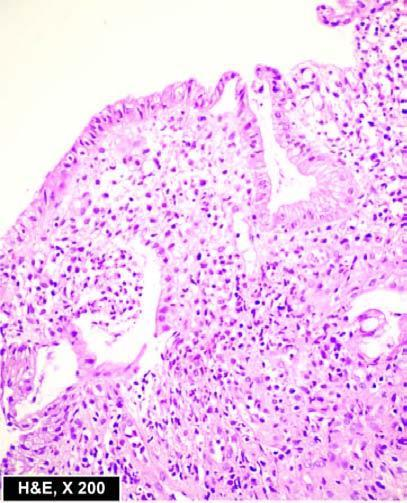what are the microscopic features seen, with mucosal infiltration by inflammatory cells and a 'crypt abscess '?
Answer the question using a single word or phrase. Superficial ulcerations 